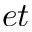Convert formula to latex. <formula><loc_0><loc_0><loc_500><loc_500>e t</formula> 